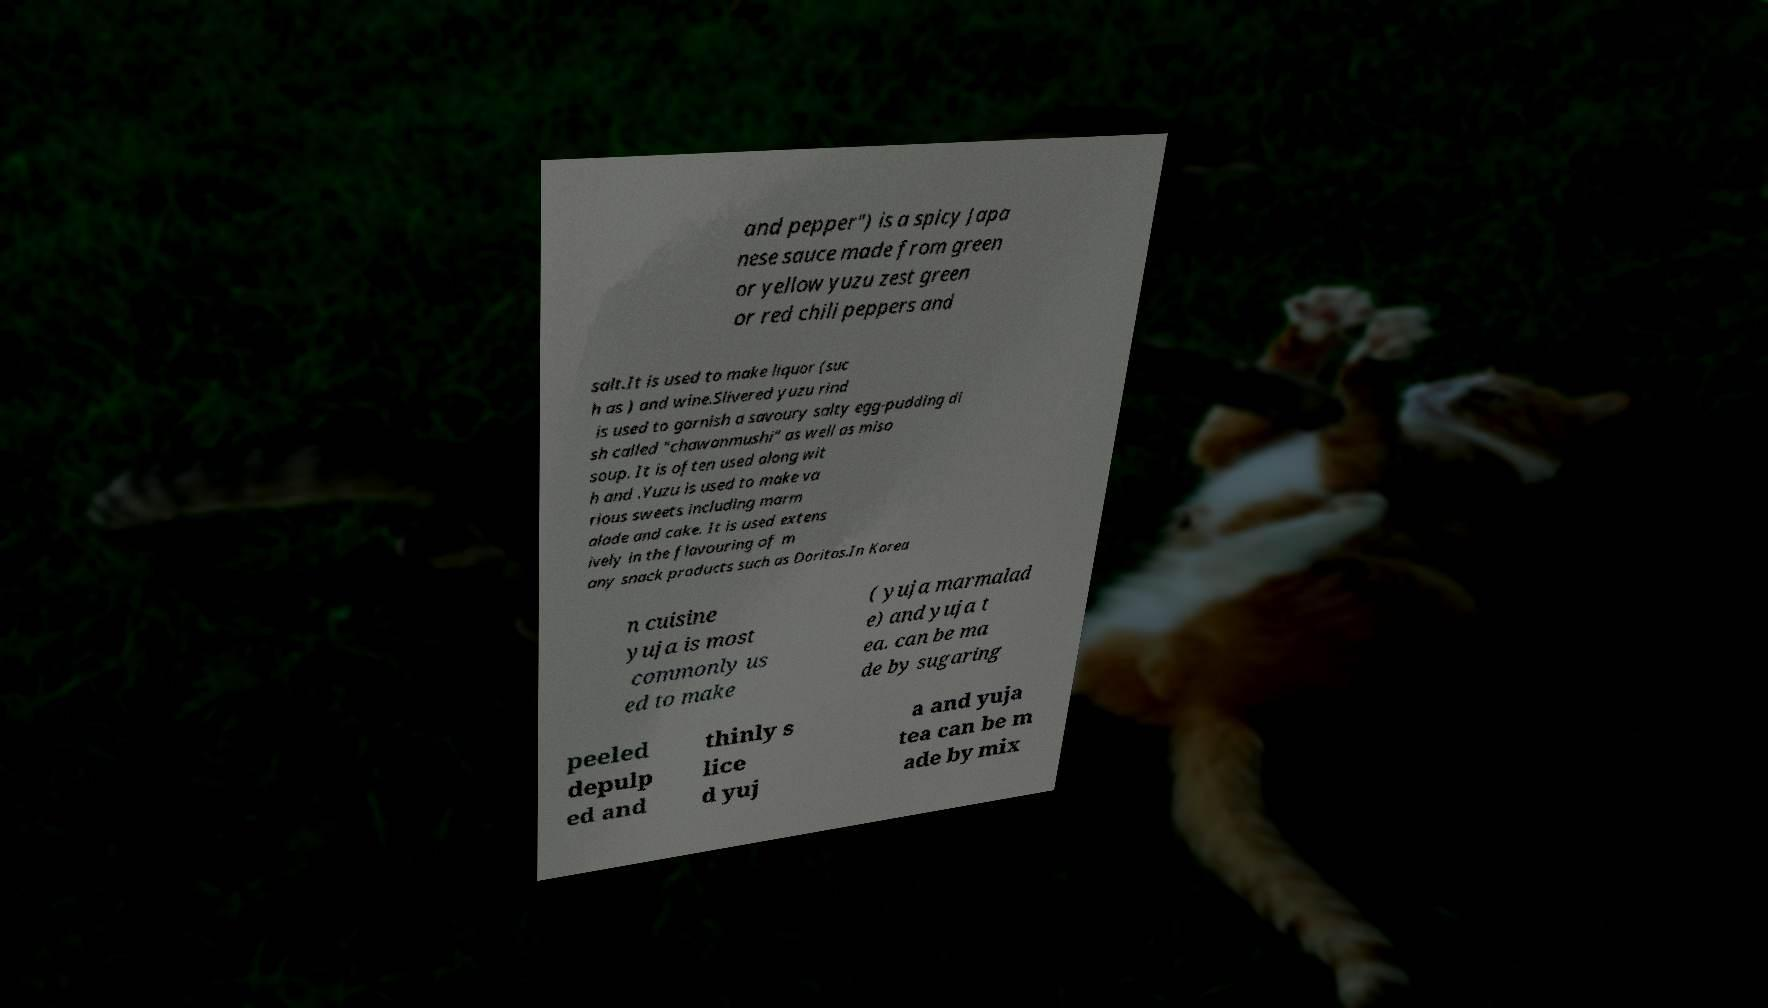I need the written content from this picture converted into text. Can you do that? and pepper") is a spicy Japa nese sauce made from green or yellow yuzu zest green or red chili peppers and salt.It is used to make liquor (suc h as ) and wine.Slivered yuzu rind is used to garnish a savoury salty egg-pudding di sh called "chawanmushi" as well as miso soup. It is often used along wit h and .Yuzu is used to make va rious sweets including marm alade and cake. It is used extens ively in the flavouring of m any snack products such as Doritos.In Korea n cuisine yuja is most commonly us ed to make ( yuja marmalad e) and yuja t ea. can be ma de by sugaring peeled depulp ed and thinly s lice d yuj a and yuja tea can be m ade by mix 